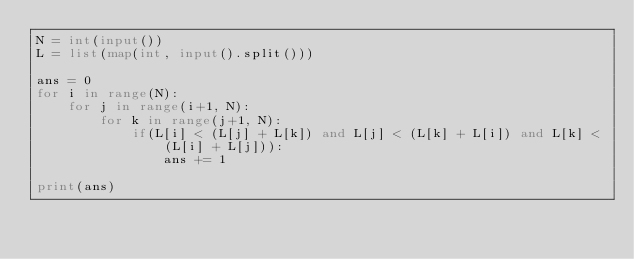<code> <loc_0><loc_0><loc_500><loc_500><_Python_>N = int(input())
L = list(map(int, input().split()))

ans = 0
for i in range(N):
    for j in range(i+1, N):
        for k in range(j+1, N):
            if(L[i] < (L[j] + L[k]) and L[j] < (L[k] + L[i]) and L[k] < (L[i] + L[j])):
                ans += 1

print(ans)</code> 